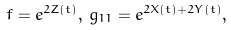<formula> <loc_0><loc_0><loc_500><loc_500>f = e ^ { 2 Z ( t ) } , \, g _ { 1 1 } = e ^ { 2 X ( t ) + 2 Y ( t ) } ,</formula> 